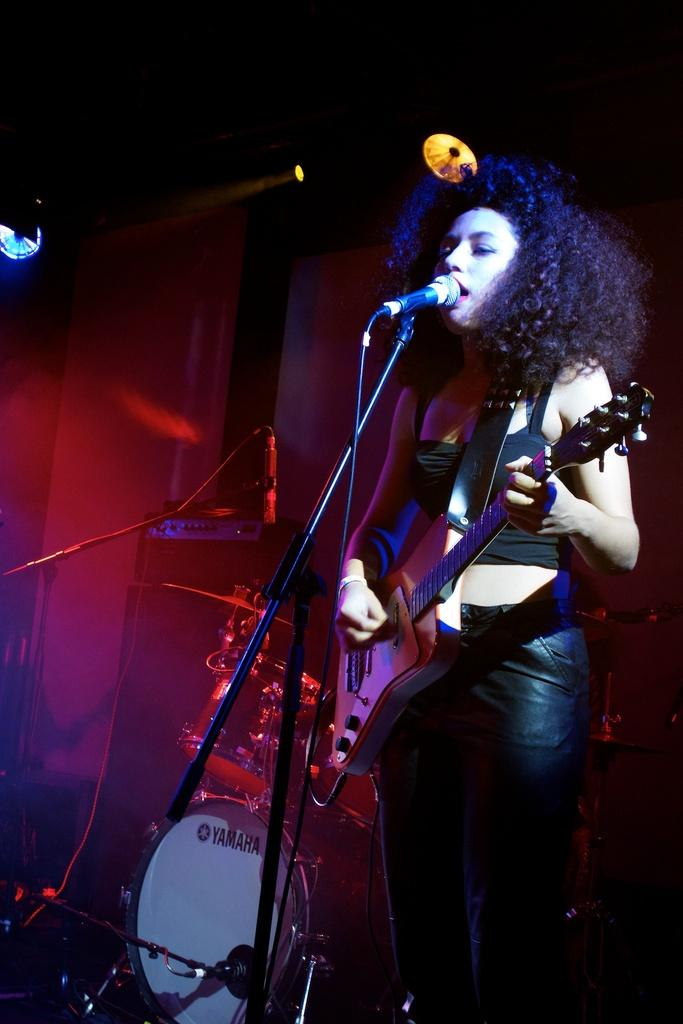What is the person in the image holding? The person is holding a guitar. What other musical instrument can be seen in the image? There is a drum in the image. What equipment is present for amplifying sound? There is a microphone with a stand in the image. What can be seen in the background of the image? There are lights visible in the background of the image. How many snails are crawling on the guitar in the image? There are no snails present in the image; the person is holding a guitar without any snails on it. What type of balloon can be seen floating in the background of the image? There are no balloons present in the image; the background features lights, not balloons. 